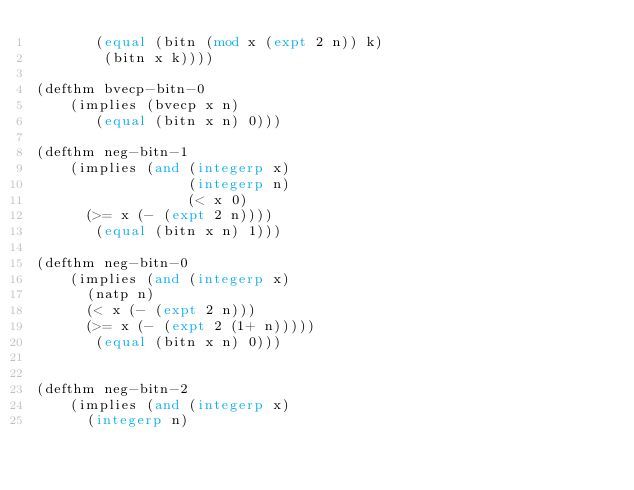Convert code to text. <code><loc_0><loc_0><loc_500><loc_500><_Lisp_>	     (equal (bitn (mod x (expt 2 n)) k)
		    (bitn x k))))

(defthm bvecp-bitn-0
    (implies (bvecp x n)
	     (equal (bitn x n) 0)))

(defthm neg-bitn-1
    (implies (and (integerp x)
                  (integerp n)
                  (< x 0)
		  (>= x (- (expt 2 n))))
	     (equal (bitn x n) 1)))

(defthm neg-bitn-0
    (implies (and (integerp x)
		  (natp n)
		  (< x (- (expt 2 n)))
		  (>= x (- (expt 2 (1+ n)))))
	     (equal (bitn x n) 0)))


(defthm neg-bitn-2
    (implies (and (integerp x)
		  (integerp n)</code> 